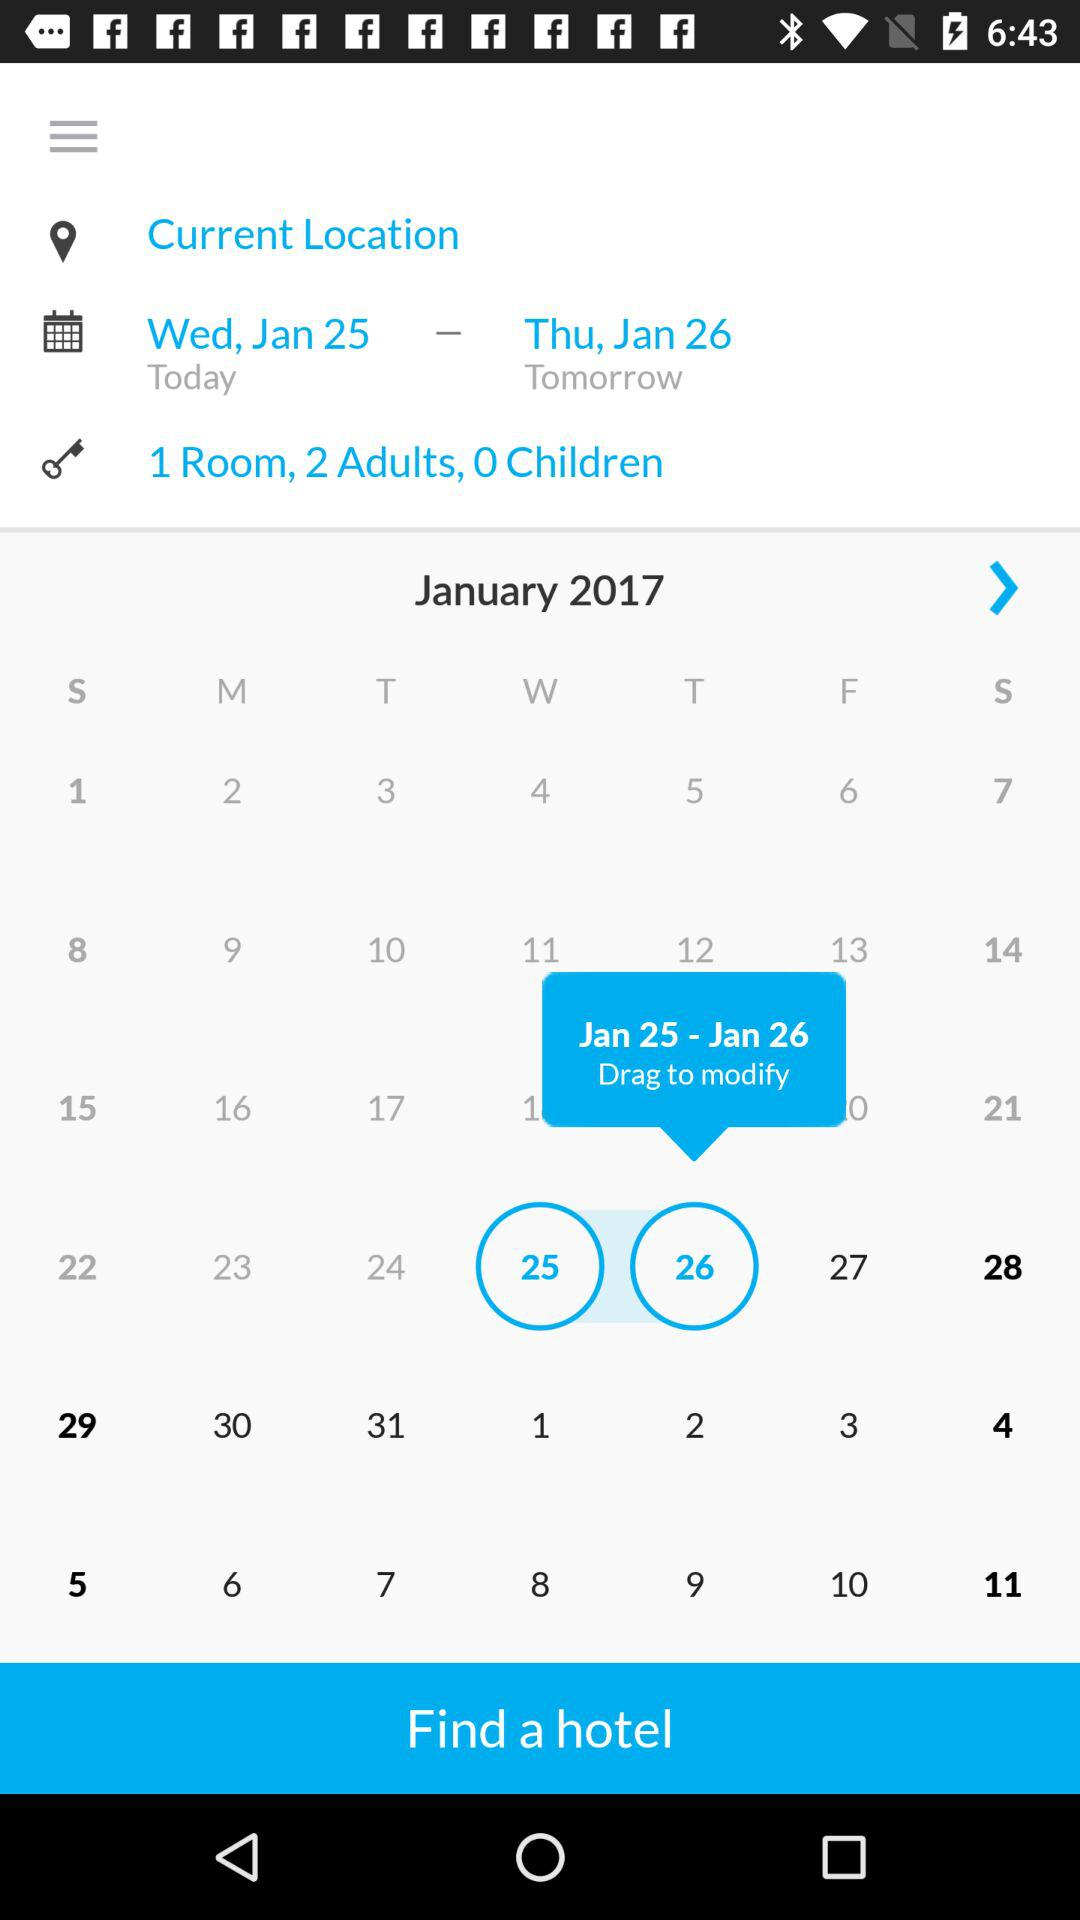How many days are selected?
Answer the question using a single word or phrase. 2 